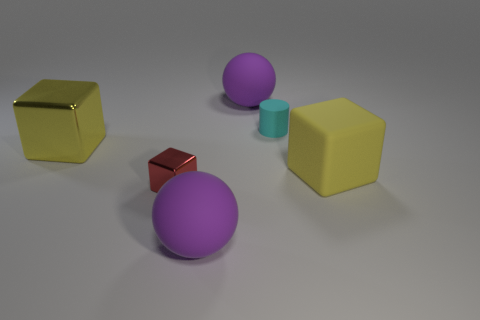There is a matte thing that is the same color as the big metal block; what shape is it?
Keep it short and to the point. Cube. There is a object that is the same color as the large metal block; what size is it?
Give a very brief answer. Large. Are there any tiny brown objects that have the same material as the small red block?
Provide a short and direct response. No. The large thing that is both behind the big matte cube and in front of the cyan cylinder has what shape?
Your answer should be very brief. Cube. How many other objects are the same shape as the small rubber object?
Provide a short and direct response. 0. What size is the cylinder?
Your answer should be very brief. Small. What number of objects are cyan rubber cylinders or small red metal blocks?
Ensure brevity in your answer.  2. There is a yellow block on the right side of the tiny cube; what size is it?
Make the answer very short. Large. Are there any other things that are the same size as the red metal thing?
Your answer should be very brief. Yes. What is the color of the matte object that is both behind the red object and in front of the small cyan cylinder?
Ensure brevity in your answer.  Yellow. 